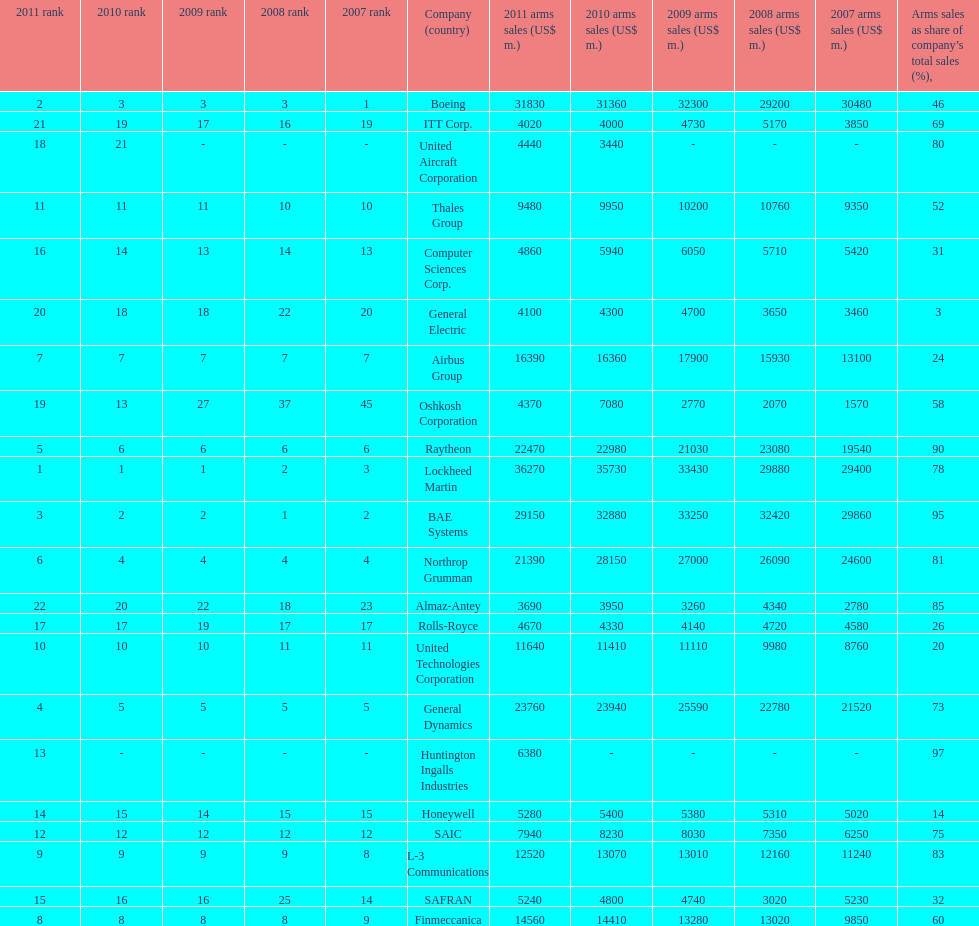What country is the first listed country? USA. 